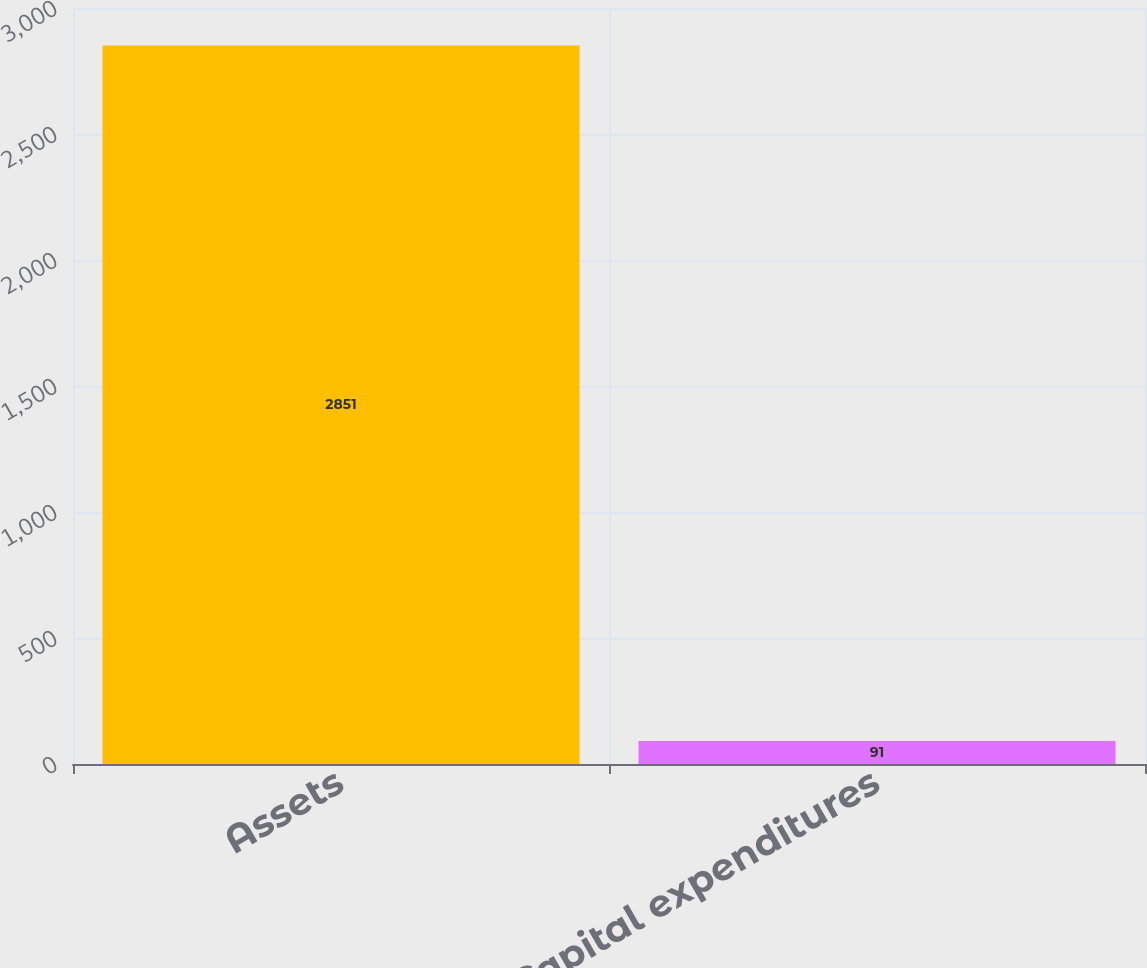Convert chart to OTSL. <chart><loc_0><loc_0><loc_500><loc_500><bar_chart><fcel>Assets<fcel>Capital expenditures<nl><fcel>2851<fcel>91<nl></chart> 